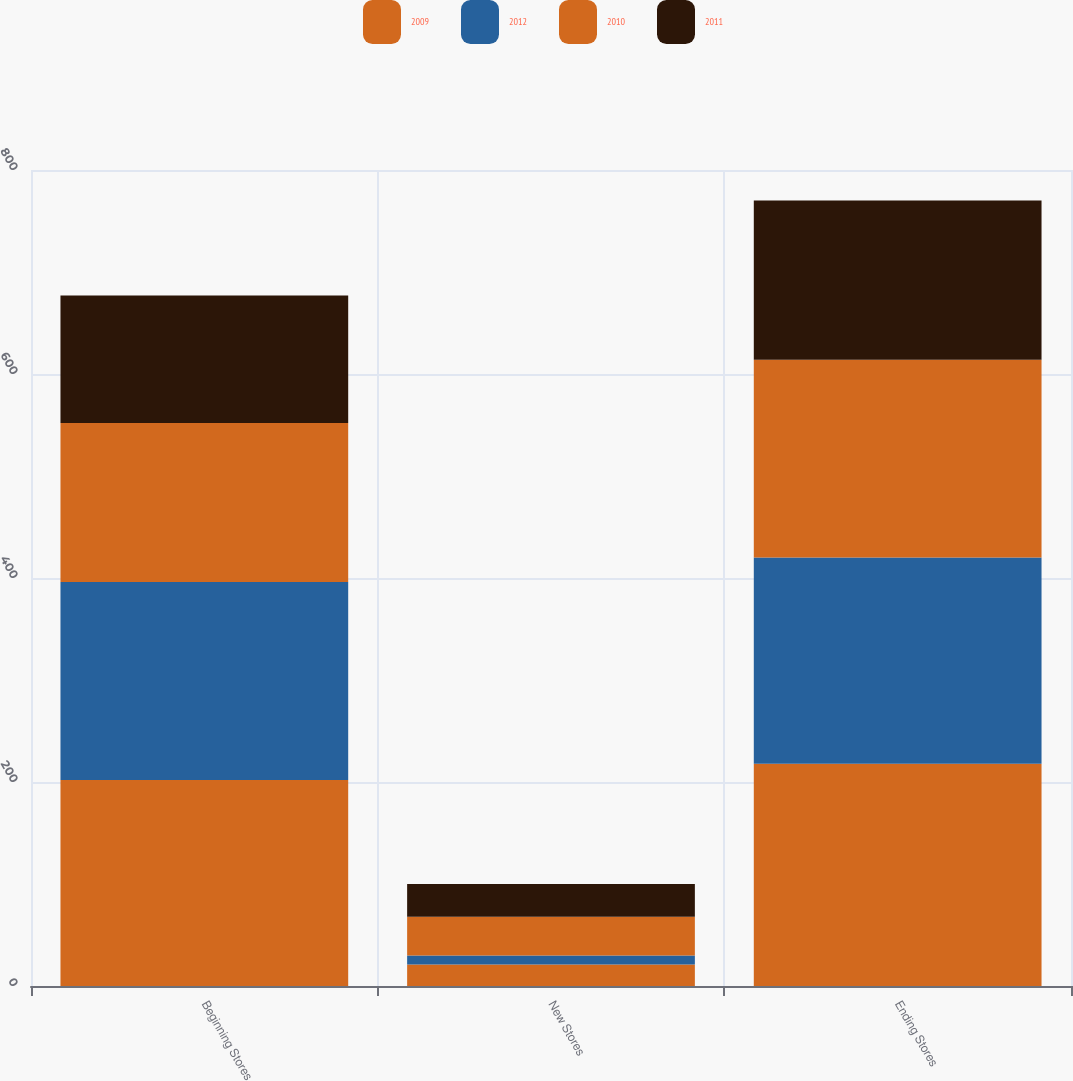Convert chart. <chart><loc_0><loc_0><loc_500><loc_500><stacked_bar_chart><ecel><fcel>Beginning Stores<fcel>New Stores<fcel>Ending Stores<nl><fcel>2009<fcel>202<fcel>21<fcel>218<nl><fcel>2012<fcel>194<fcel>9<fcel>202<nl><fcel>2010<fcel>156<fcel>38<fcel>194<nl><fcel>2011<fcel>125<fcel>32<fcel>156<nl></chart> 